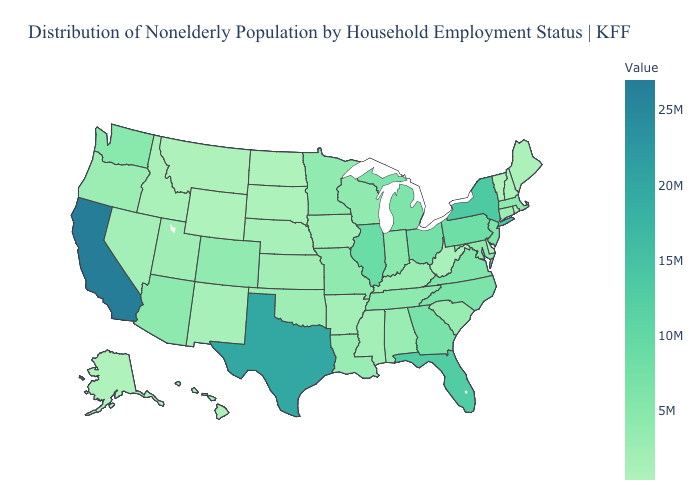Among the states that border Pennsylvania , which have the highest value?
Give a very brief answer. New York. Which states have the highest value in the USA?
Be succinct. California. Which states have the lowest value in the USA?
Quick response, please. Vermont. Which states have the highest value in the USA?
Short answer required. California. Does Oklahoma have the lowest value in the USA?
Write a very short answer. No. Which states have the lowest value in the West?
Be succinct. Wyoming. 